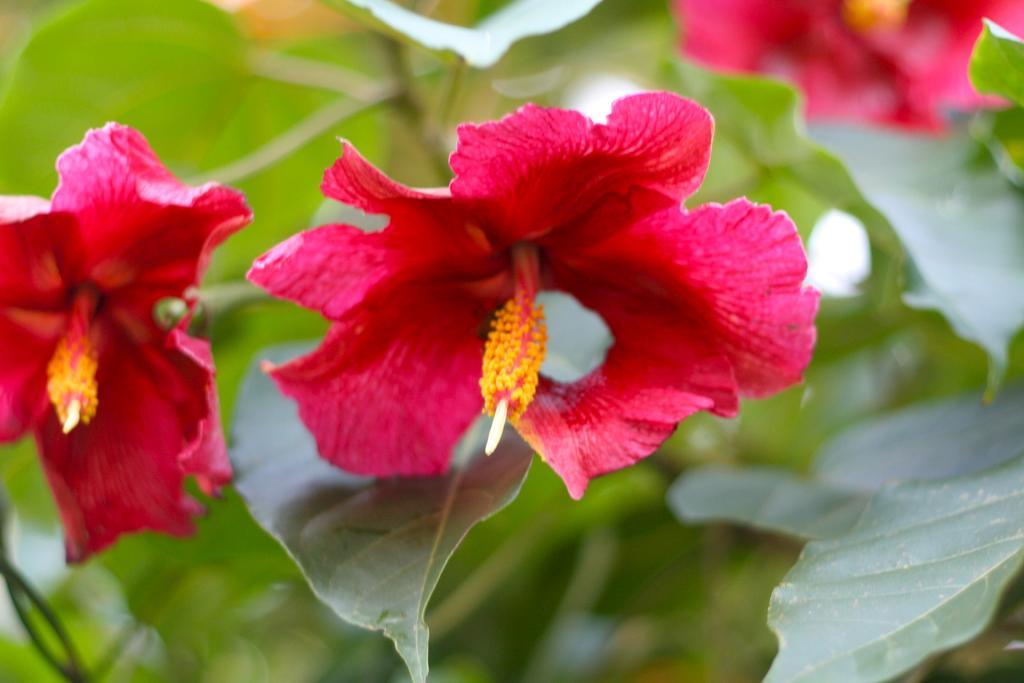How would you summarize this image in a sentence or two? In this image I can see few flowers which are pink, red and yellow in color to a plant which is green in color. I can see the blurry background. 